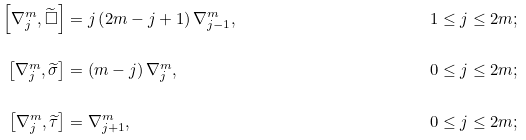<formula> <loc_0><loc_0><loc_500><loc_500>\left [ \nabla _ { j } ^ { m } , \widetilde { \square } \right ] & = j \left ( 2 m - j + 1 \right ) \nabla _ { j - 1 } ^ { m } , & 1 & \leq j \leq 2 m ; \\ \left [ \nabla _ { j } ^ { m } , \widetilde { \sigma } \right ] & = \left ( m - j \right ) \nabla _ { j } ^ { m } , & 0 & \leq j \leq 2 m ; \\ \left [ \nabla _ { j } ^ { m } , \widetilde { \tau } \right ] & = \nabla _ { j + 1 } ^ { m } , & 0 & \leq j \leq 2 m ;</formula> 